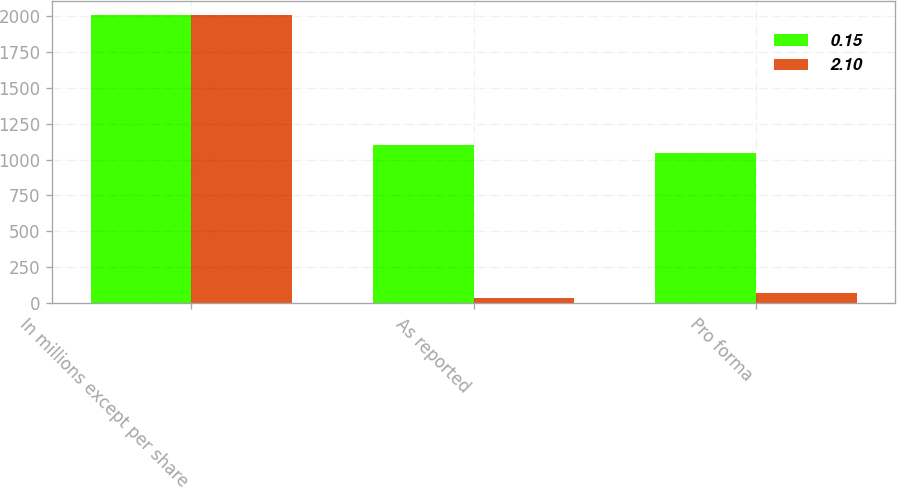Convert chart to OTSL. <chart><loc_0><loc_0><loc_500><loc_500><stacked_bar_chart><ecel><fcel>In millions except per share<fcel>As reported<fcel>Pro forma<nl><fcel>0.15<fcel>2005<fcel>1100<fcel>1043<nl><fcel>2.1<fcel>2004<fcel>35<fcel>73<nl></chart> 